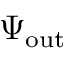Convert formula to latex. <formula><loc_0><loc_0><loc_500><loc_500>\Psi _ { o u t }</formula> 